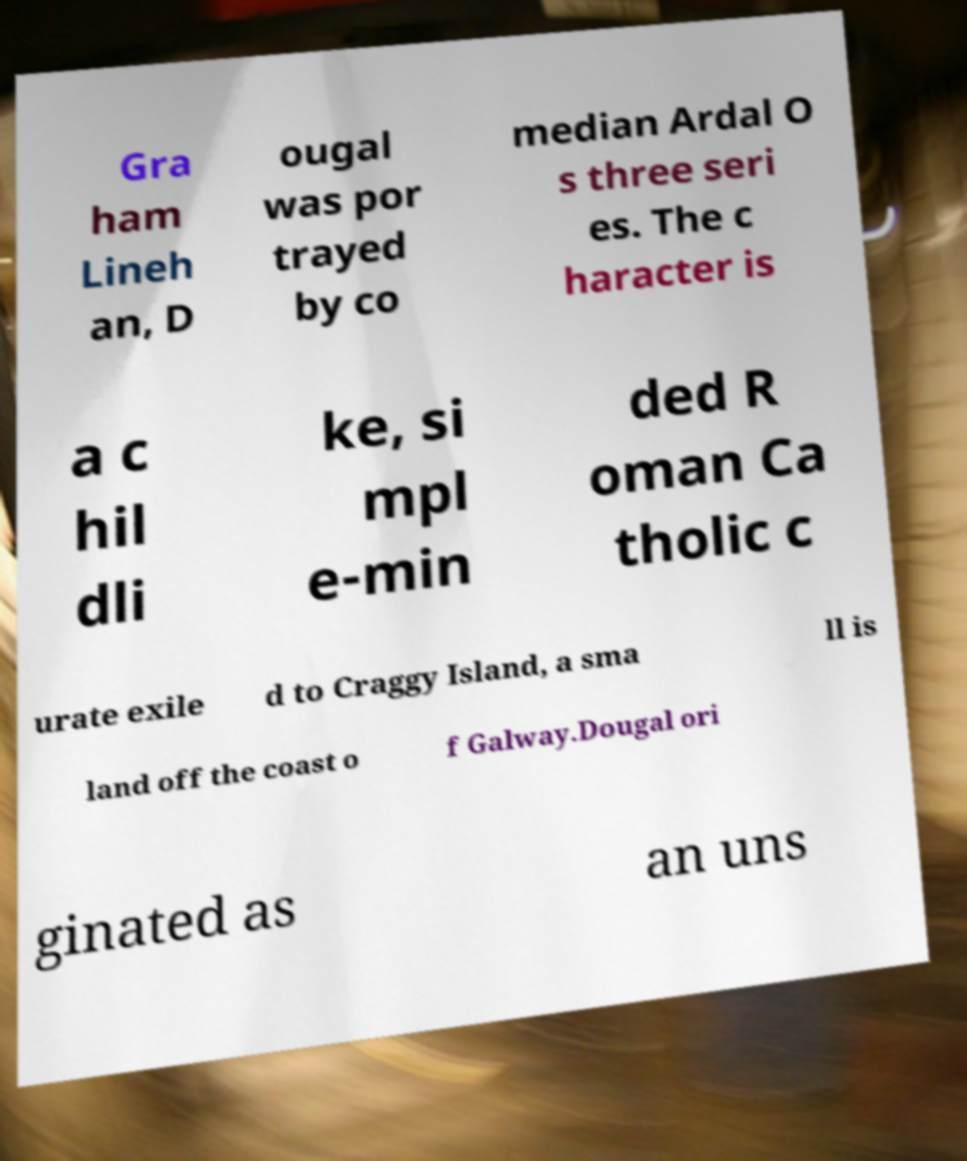Please identify and transcribe the text found in this image. Gra ham Lineh an, D ougal was por trayed by co median Ardal O s three seri es. The c haracter is a c hil dli ke, si mpl e-min ded R oman Ca tholic c urate exile d to Craggy Island, a sma ll is land off the coast o f Galway.Dougal ori ginated as an uns 